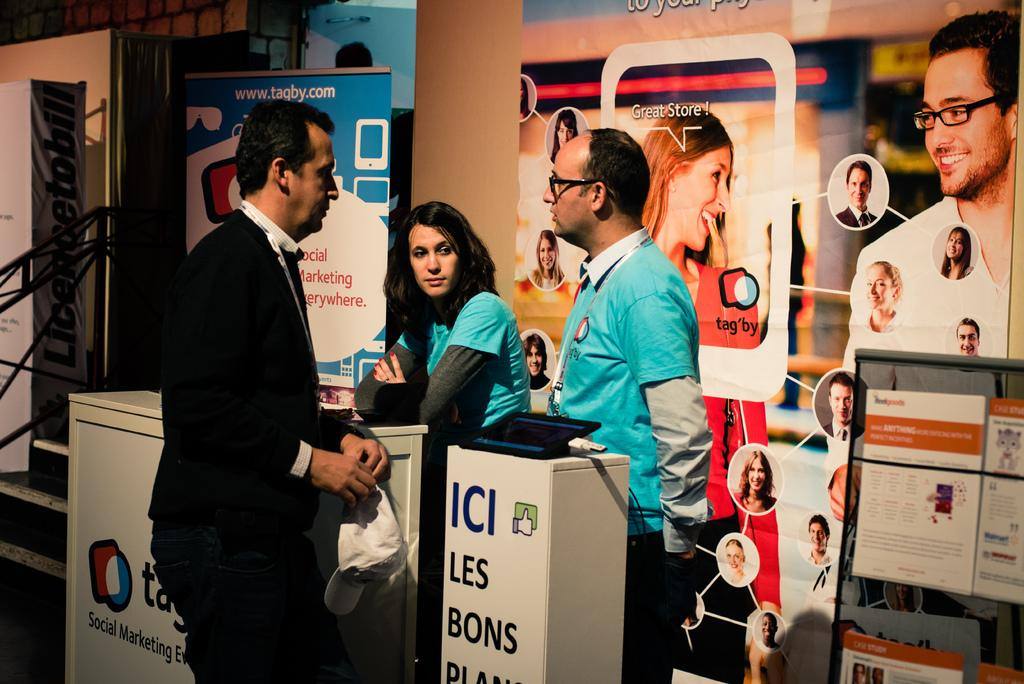How many people are in the image? There are three persons standing in the center of the image. What can be seen in the background of the image? There are advertisement boards, a wall, a railing, and a staircase in the background of the image. What type of wound can be seen on the baby in the image? There is no baby present in the image, so it is not possible to determine if there is a wound or not. 